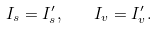Convert formula to latex. <formula><loc_0><loc_0><loc_500><loc_500>I _ { s } = I _ { s } ^ { \prime } , \quad I _ { v } = I _ { v } ^ { \prime } .</formula> 